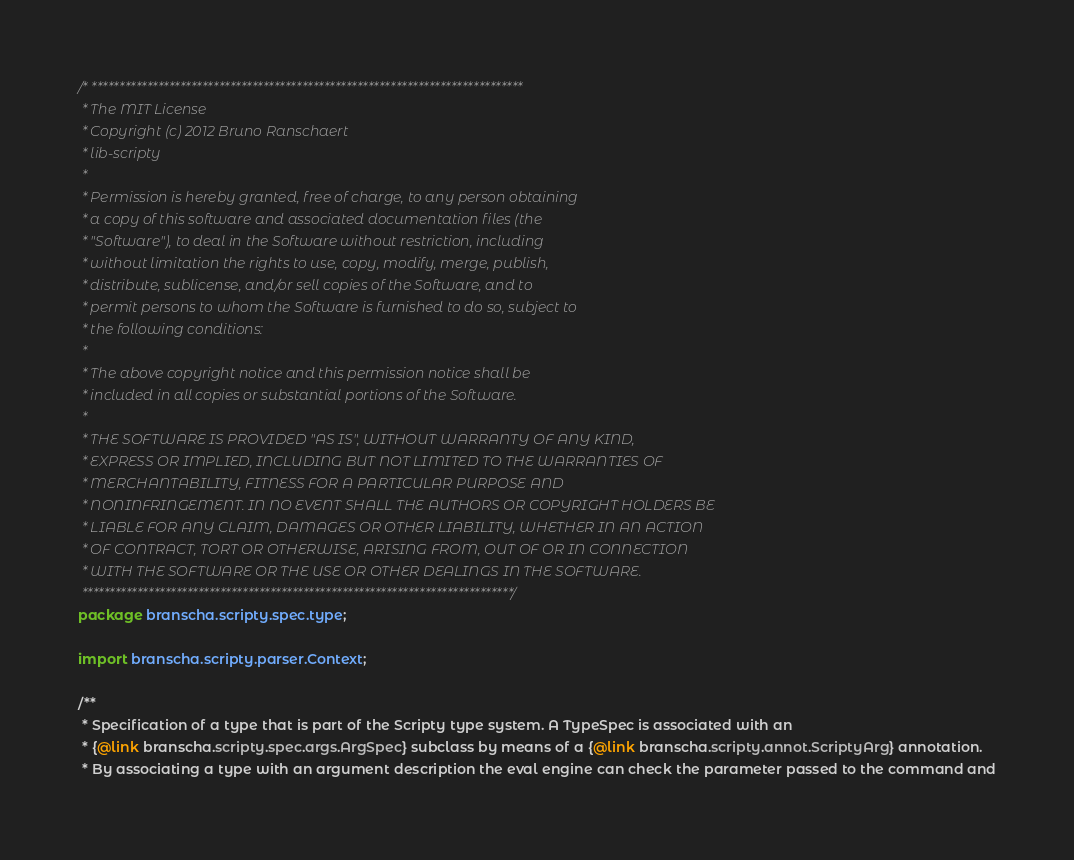<code> <loc_0><loc_0><loc_500><loc_500><_Java_>/* ******************************************************************************
 * The MIT License
 * Copyright (c) 2012 Bruno Ranschaert
 * lib-scripty
 *
 * Permission is hereby granted, free of charge, to any person obtaining
 * a copy of this software and associated documentation files (the
 * "Software"), to deal in the Software without restriction, including
 * without limitation the rights to use, copy, modify, merge, publish,
 * distribute, sublicense, and/or sell copies of the Software, and to
 * permit persons to whom the Software is furnished to do so, subject to
 * the following conditions:
 *
 * The above copyright notice and this permission notice shall be
 * included in all copies or substantial portions of the Software.
 *
 * THE SOFTWARE IS PROVIDED "AS IS", WITHOUT WARRANTY OF ANY KIND,
 * EXPRESS OR IMPLIED, INCLUDING BUT NOT LIMITED TO THE WARRANTIES OF
 * MERCHANTABILITY, FITNESS FOR A PARTICULAR PURPOSE AND
 * NONINFRINGEMENT. IN NO EVENT SHALL THE AUTHORS OR COPYRIGHT HOLDERS BE
 * LIABLE FOR ANY CLAIM, DAMAGES OR OTHER LIABILITY, WHETHER IN AN ACTION
 * OF CONTRACT, TORT OR OTHERWISE, ARISING FROM, OUT OF OR IN CONNECTION
 * WITH THE SOFTWARE OR THE USE OR OTHER DEALINGS IN THE SOFTWARE.
 ******************************************************************************/
package branscha.scripty.spec.type;

import branscha.scripty.parser.Context;

/**
 * Specification of a type that is part of the Scripty type system. A TypeSpec is associated with an
 * {@link branscha.scripty.spec.args.ArgSpec} subclass by means of a {@link branscha.scripty.annot.ScriptyArg} annotation.
 * By associating a type with an argument description the eval engine can check the parameter passed to the command and</code> 